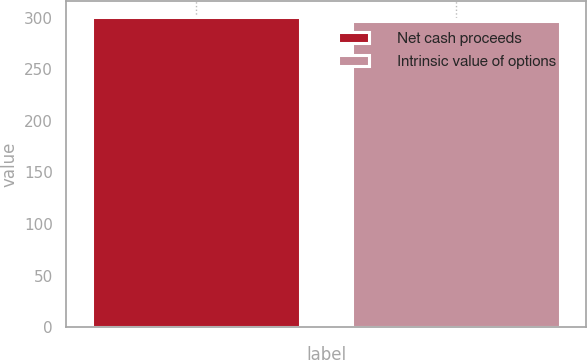Convert chart. <chart><loc_0><loc_0><loc_500><loc_500><bar_chart><fcel>Net cash proceeds<fcel>Intrinsic value of options<nl><fcel>300.8<fcel>297.2<nl></chart> 